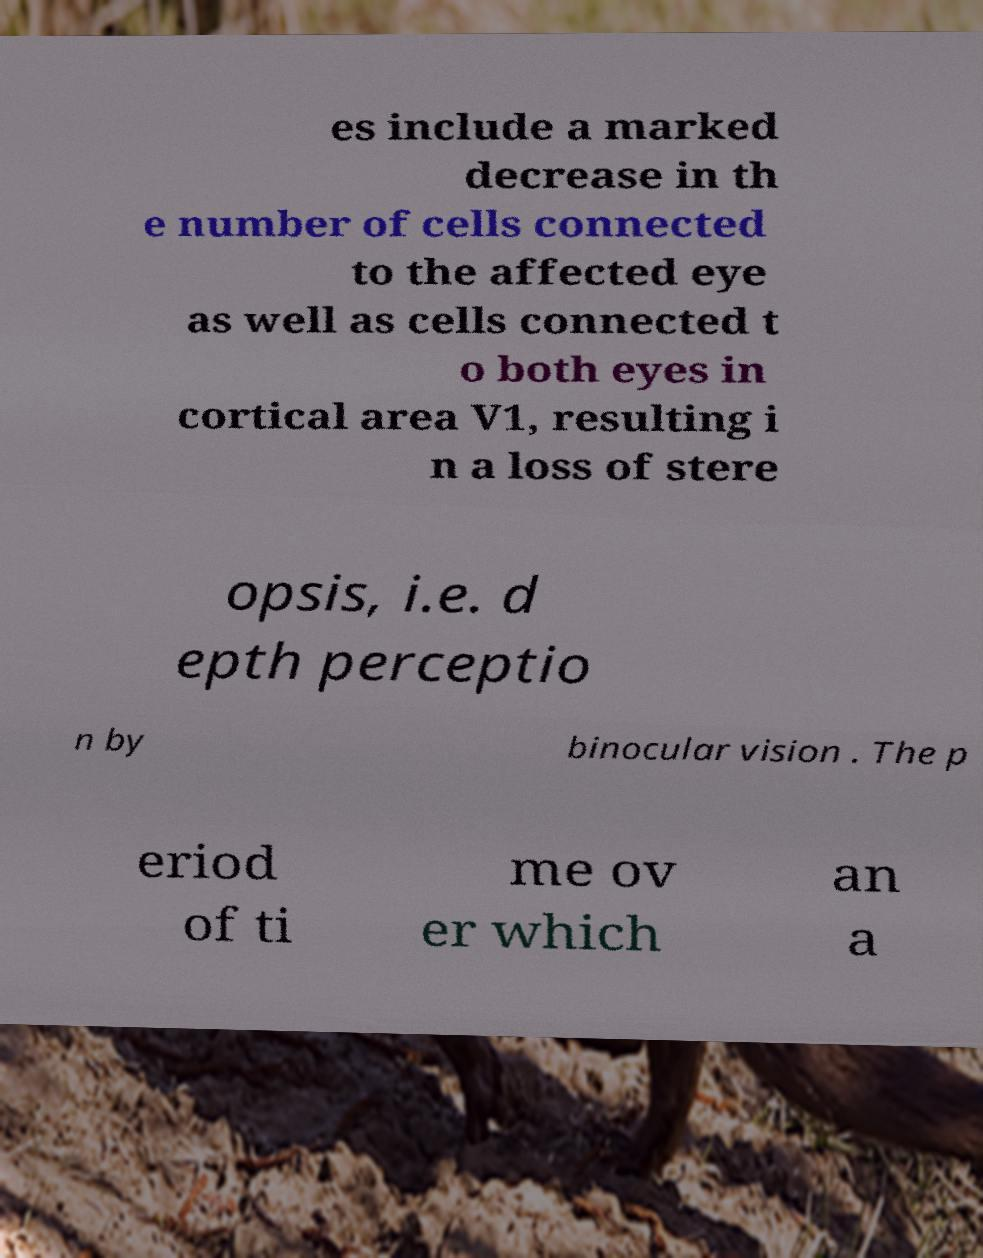I need the written content from this picture converted into text. Can you do that? es include a marked decrease in th e number of cells connected to the affected eye as well as cells connected t o both eyes in cortical area V1, resulting i n a loss of stere opsis, i.e. d epth perceptio n by binocular vision . The p eriod of ti me ov er which an a 